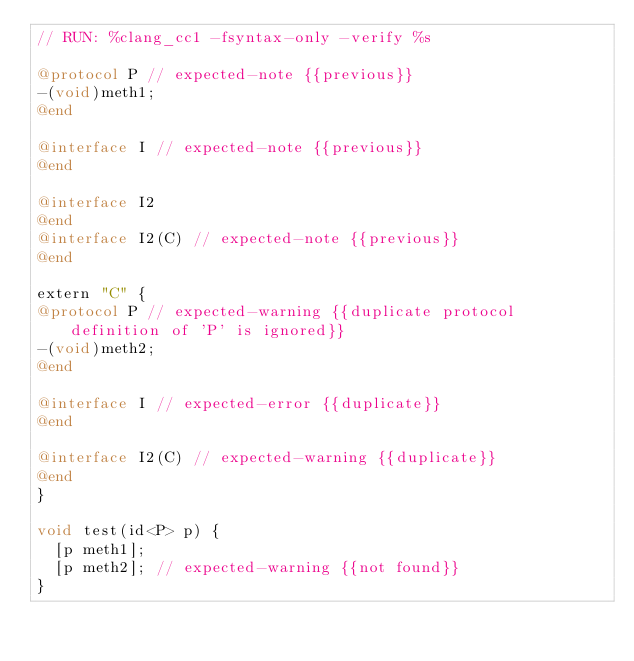Convert code to text. <code><loc_0><loc_0><loc_500><loc_500><_ObjectiveC_>// RUN: %clang_cc1 -fsyntax-only -verify %s

@protocol P // expected-note {{previous}}
-(void)meth1;
@end

@interface I // expected-note {{previous}}
@end

@interface I2
@end
@interface I2(C) // expected-note {{previous}}
@end

extern "C" {
@protocol P // expected-warning {{duplicate protocol definition of 'P' is ignored}}
-(void)meth2;
@end

@interface I // expected-error {{duplicate}}
@end

@interface I2(C) // expected-warning {{duplicate}}
@end
}

void test(id<P> p) {
  [p meth1];
  [p meth2]; // expected-warning {{not found}}
}
</code> 